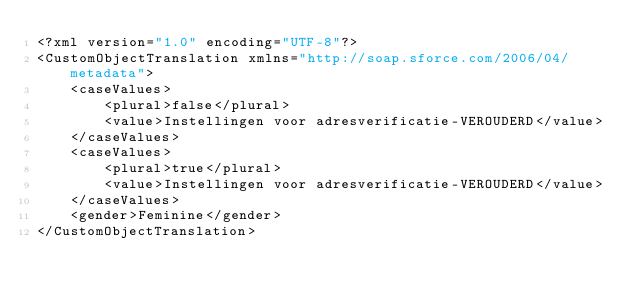<code> <loc_0><loc_0><loc_500><loc_500><_XML_><?xml version="1.0" encoding="UTF-8"?>
<CustomObjectTranslation xmlns="http://soap.sforce.com/2006/04/metadata">
    <caseValues>
        <plural>false</plural>
        <value>Instellingen voor adresverificatie-VEROUDERD</value>
    </caseValues>
    <caseValues>
        <plural>true</plural>
        <value>Instellingen voor adresverificatie-VEROUDERD</value>
    </caseValues>
    <gender>Feminine</gender>
</CustomObjectTranslation>
</code> 